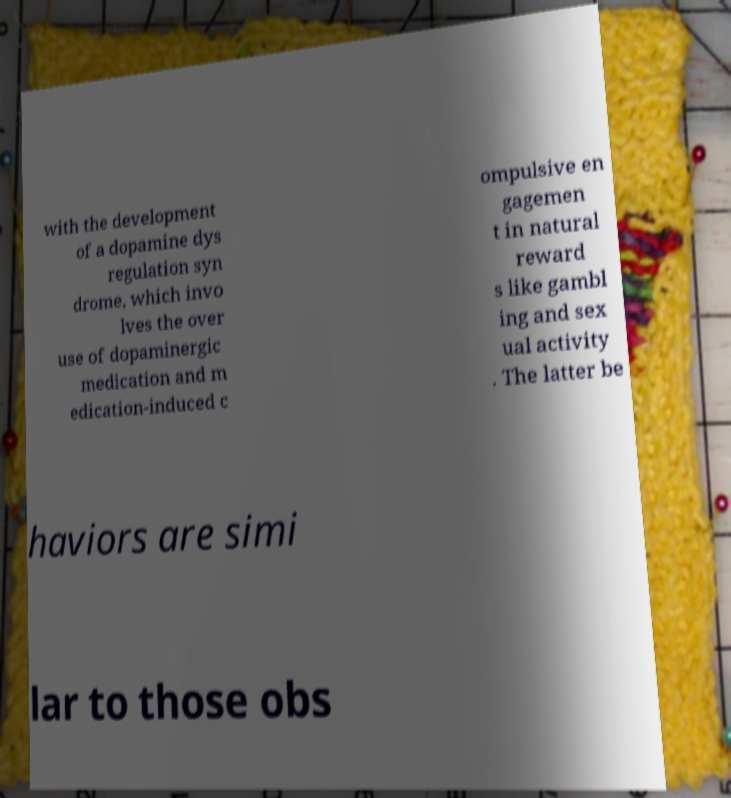Can you read and provide the text displayed in the image?This photo seems to have some interesting text. Can you extract and type it out for me? with the development of a dopamine dys regulation syn drome, which invo lves the over use of dopaminergic medication and m edication-induced c ompulsive en gagemen t in natural reward s like gambl ing and sex ual activity . The latter be haviors are simi lar to those obs 